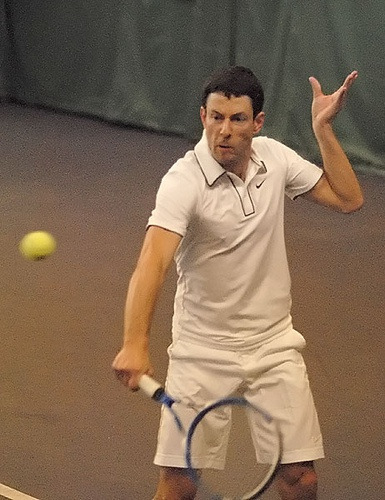Describe the objects in this image and their specific colors. I can see people in black, tan, and gray tones, tennis racket in black, gray, and tan tones, and sports ball in black, khaki, tan, and olive tones in this image. 